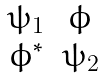Convert formula to latex. <formula><loc_0><loc_0><loc_500><loc_500>\begin{matrix} \psi _ { 1 } & \phi \\ \phi ^ { * } & \psi _ { 2 } \end{matrix}</formula> 